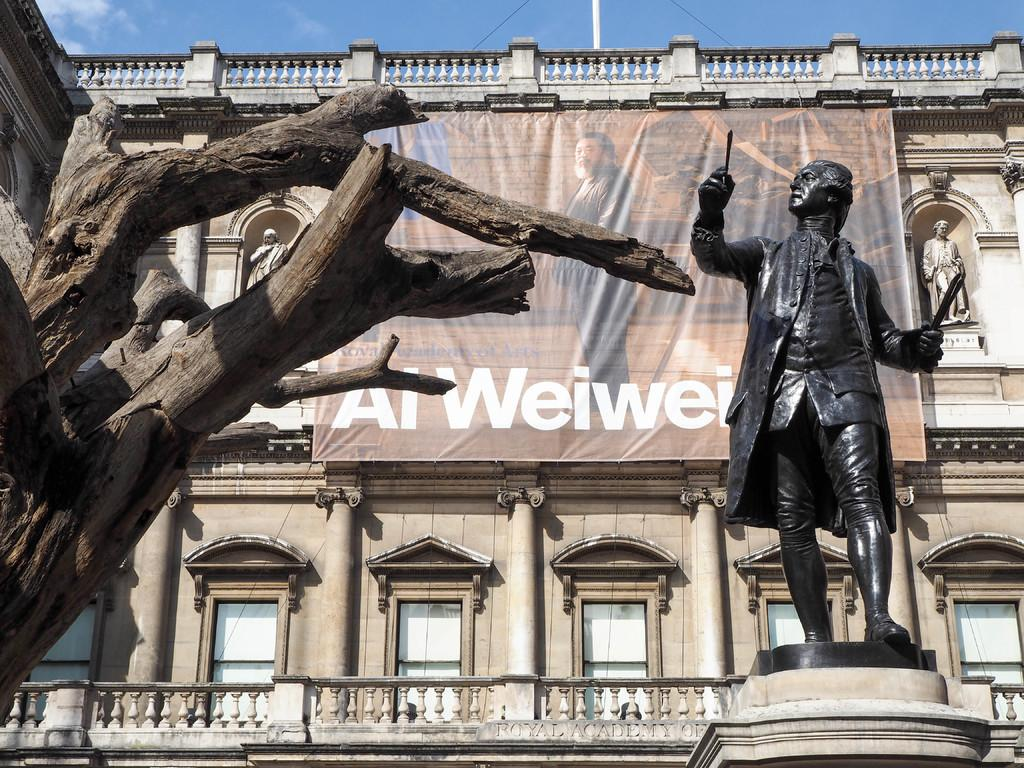<image>
Summarize the visual content of the image. Large statue outside of a building that has a poster that says "Al Weiwei". 